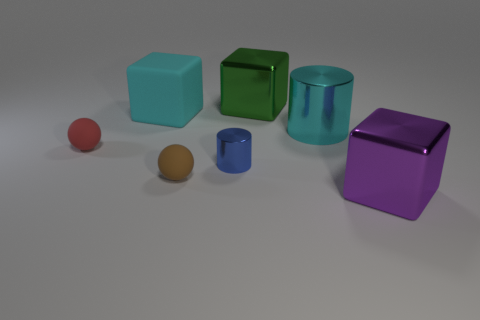Add 1 large green metal blocks. How many objects exist? 8 Subtract all large metallic cubes. How many cubes are left? 1 Subtract all yellow blocks. Subtract all red spheres. How many blocks are left? 3 Subtract all cylinders. How many objects are left? 5 Add 1 large green metallic blocks. How many large green metallic blocks exist? 2 Subtract 0 red cubes. How many objects are left? 7 Subtract all tiny gray blocks. Subtract all big purple shiny things. How many objects are left? 6 Add 3 blue objects. How many blue objects are left? 4 